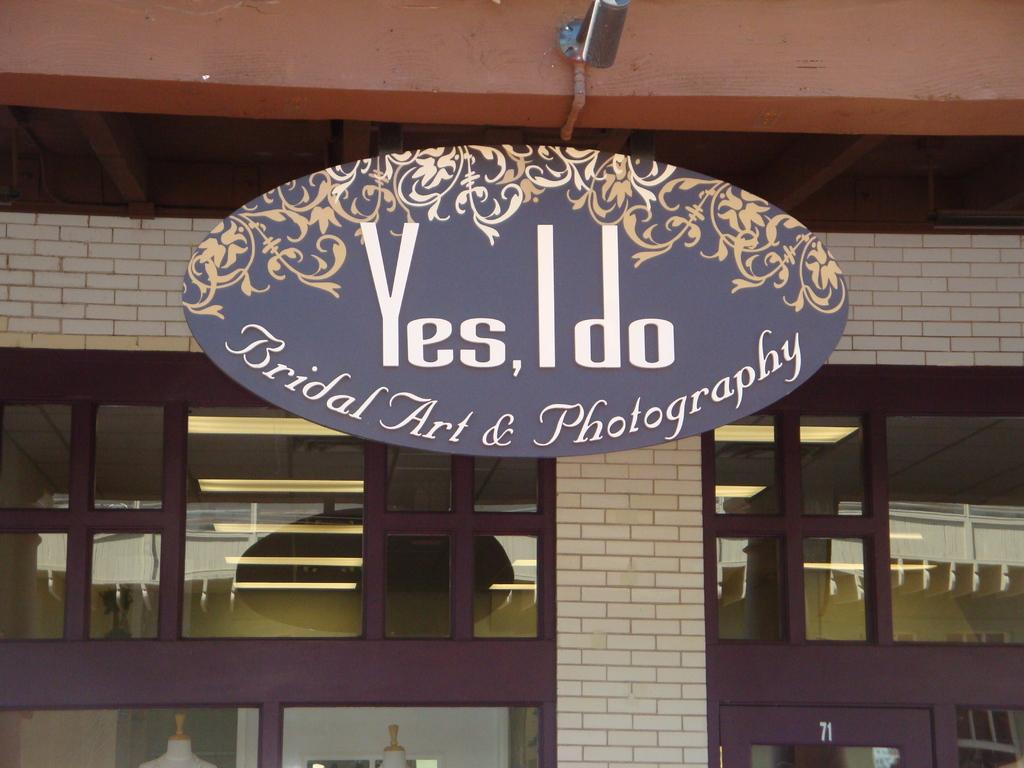<image>
Share a concise interpretation of the image provided. A shop specialized in Bridal Photography saying YES I DO 